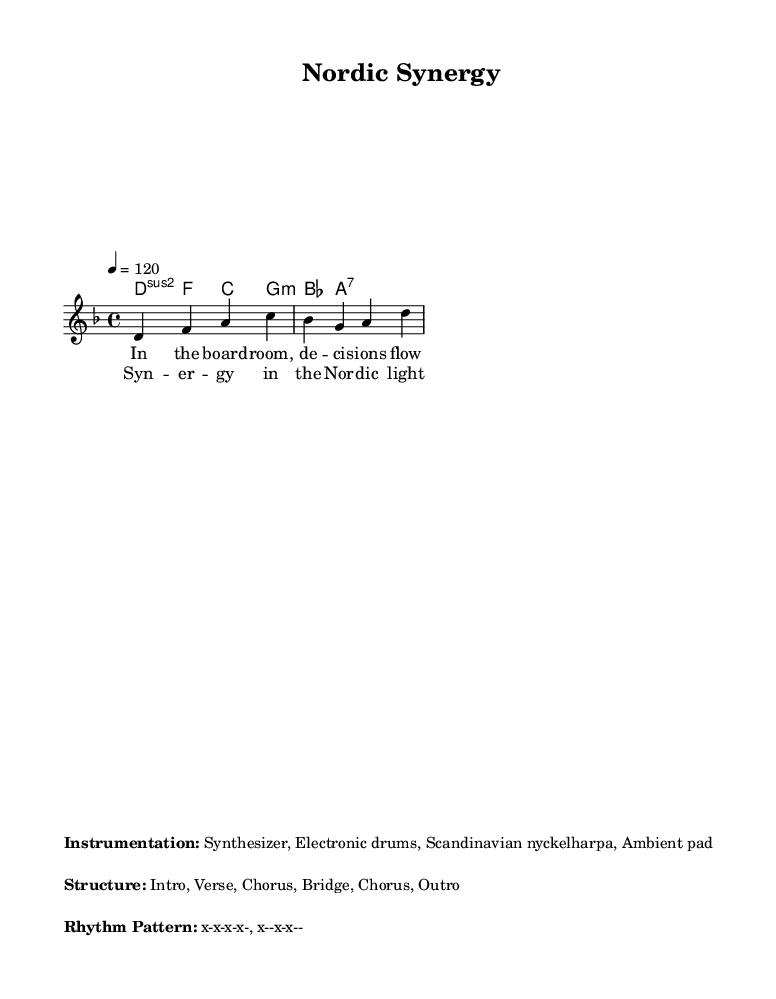What is the key signature of this music? The key signature is indicated near the beginning of the score, where it shows two flats, which corresponds to D minor.
Answer: D minor What is the time signature of this composition? The time signature is found at the beginning of the score, represented as 4/4. This indicates that there are four beats in each measure.
Answer: 4/4 What is the tempo marking of the piece? The tempo marking specifies the speed of the music and is given in beats per minute, which in this score is indicated as 120.
Answer: 120 Which instrument is specifically mentioned in the instrumentation? The instrumentation section lists the synth, electronic drums, and Scandinavian nyckelharpa as key components. The nyckelharpa is particularly highlighted as a unique instrument in this style.
Answer: Scandinavian nyckelharpa What does the term 'Synergy' refer to in this music context? The term 'Synergy' in the chorus likely reflects a theme of collaboration and unity in leadership and decision-making, aligning with corporate strategy concepts.
Answer: Collaboration How many sections does this piece have? The structure as noted in the markup outlines five distinct sections: Intro, Verse, Chorus, Bridge, Chorus, and Outro.
Answer: Five What type of rhythm pattern is indicated in the score? The rhythm pattern is specified in the markup section under "Rhythm Pattern," which illustrates a consistent alternating pattern typical in electronic music. The pattern is described as x-x-x-x-, x--x-x--.
Answer: x-x-x-x-, x--x-x-- 